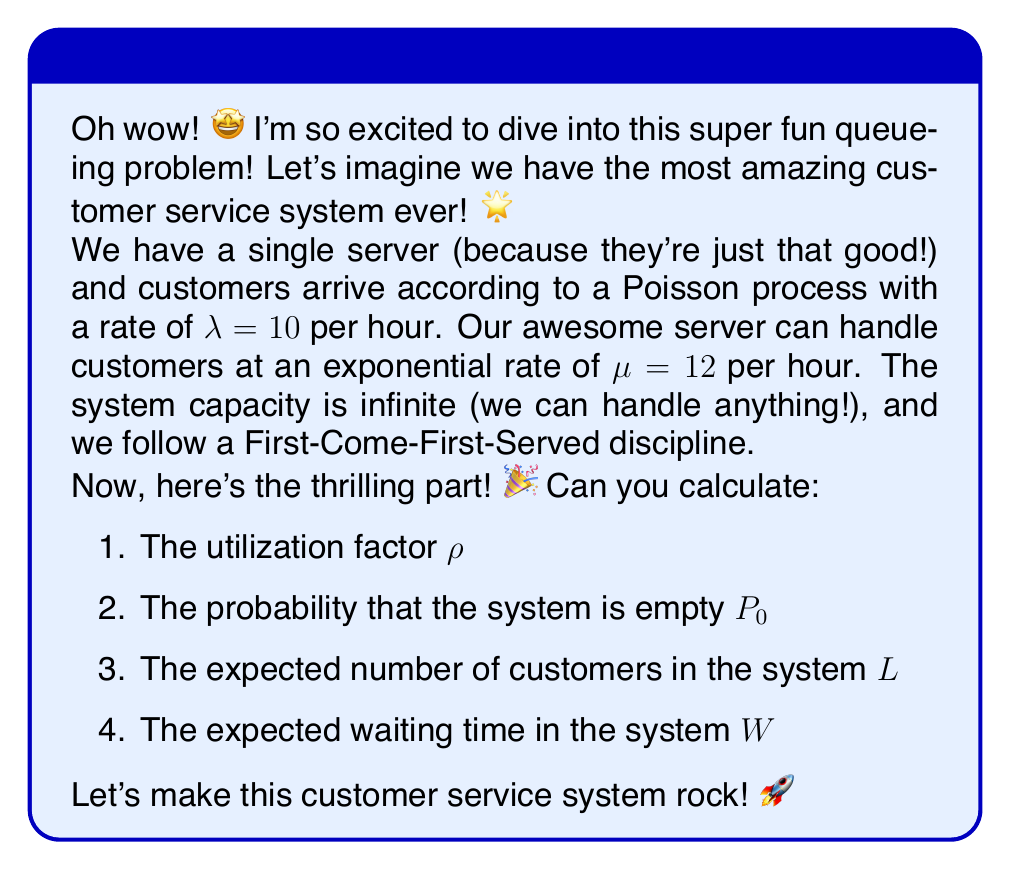Solve this math problem. Woohoo! Let's break this down step-by-step and have a blast solving this problem! 😄

Step 1: Calculate the utilization factor $\rho$
The utilization factor is the ratio of arrival rate to service rate:
$$\rho = \frac{\lambda}{\mu} = \frac{10}{12} \approx 0.8333$$

Step 2: Calculate the probability that the system is empty $P_0$
For an M/M/1 queue (which is what we have here), the probability of an empty system is:
$$P_0 = 1 - \rho = 1 - 0.8333 \approx 0.1667$$

Step 3: Calculate the expected number of customers in the system $L$
For an M/M/1 queue, we use the formula:
$$L = \frac{\rho}{1-\rho} = \frac{0.8333}{1-0.8333} \approx 5$$

Step 4: Calculate the expected waiting time in the system $W$
We can use Little's Law for this: $L = \lambda W$
Rearranging, we get:
$$W = \frac{L}{\lambda} = \frac{5}{10} = 0.5\text{ hours} = 30\text{ minutes}$$

Isn't it amazing how all these numbers come together? 🌈 Our customer service system is running smoothly, with an average of 5 customers in the system and a waiting time of 30 minutes. Not too shabby! 🎊
Answer: $\rho \approx 0.8333$, $P_0 \approx 0.1667$, $L \approx 5$, $W = 30$ minutes 